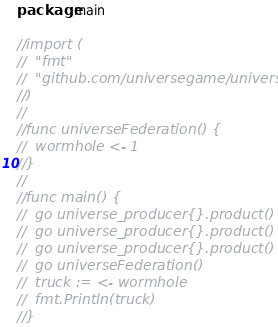<code> <loc_0><loc_0><loc_500><loc_500><_Go_>package main

//import (
//	"fmt"
//	"github.com/universegame/universes"
//)
//
//func universeFederation() {
//	wormhole <- 1
//}
//
//func main() {
//	go universe_producer{}.product()
//	go universe_producer{}.product()
//	go universe_producer{}.product()
//	go universeFederation()
//	truck := <- wormhole
//	fmt.Println(truck)
//}
</code> 